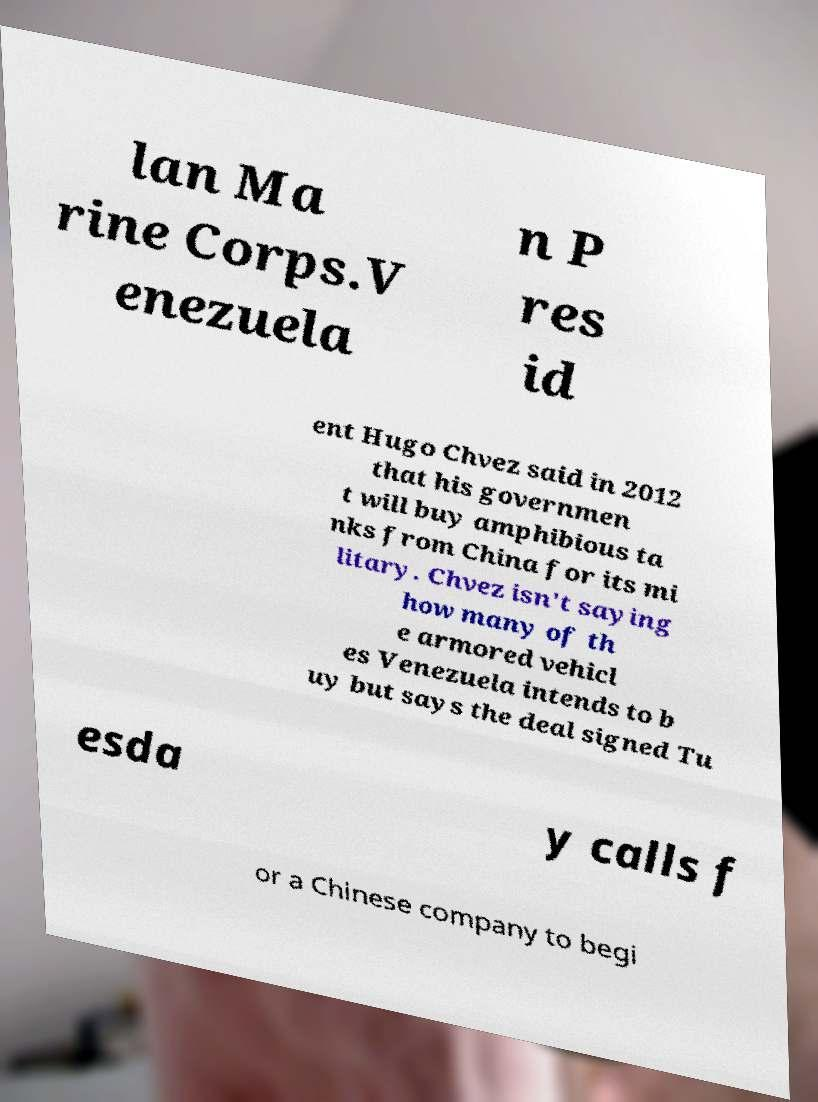Please read and relay the text visible in this image. What does it say? lan Ma rine Corps.V enezuela n P res id ent Hugo Chvez said in 2012 that his governmen t will buy amphibious ta nks from China for its mi litary. Chvez isn't saying how many of th e armored vehicl es Venezuela intends to b uy but says the deal signed Tu esda y calls f or a Chinese company to begi 